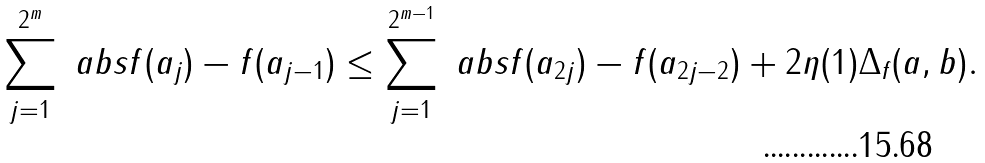Convert formula to latex. <formula><loc_0><loc_0><loc_500><loc_500>\sum _ { j = 1 } ^ { 2 ^ { m } } \ a b s { f ( a _ { j } ) - f ( a _ { j - 1 } ) } \leq \sum _ { j = 1 } ^ { 2 ^ { m - 1 } } \ a b s { f ( a _ { 2 j } ) - f ( a _ { 2 j - 2 } ) } + 2 \eta ( 1 ) \Delta _ { f } ( a , b ) .</formula> 